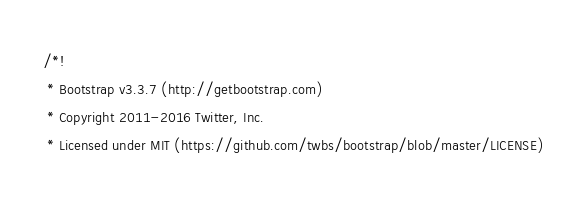<code> <loc_0><loc_0><loc_500><loc_500><_CSS_>/*!
 * Bootstrap v3.3.7 (http://getbootstrap.com)
 * Copyright 2011-2016 Twitter, Inc.
 * Licensed under MIT (https://github.com/twbs/bootstrap/blob/master/LICENSE)</code> 